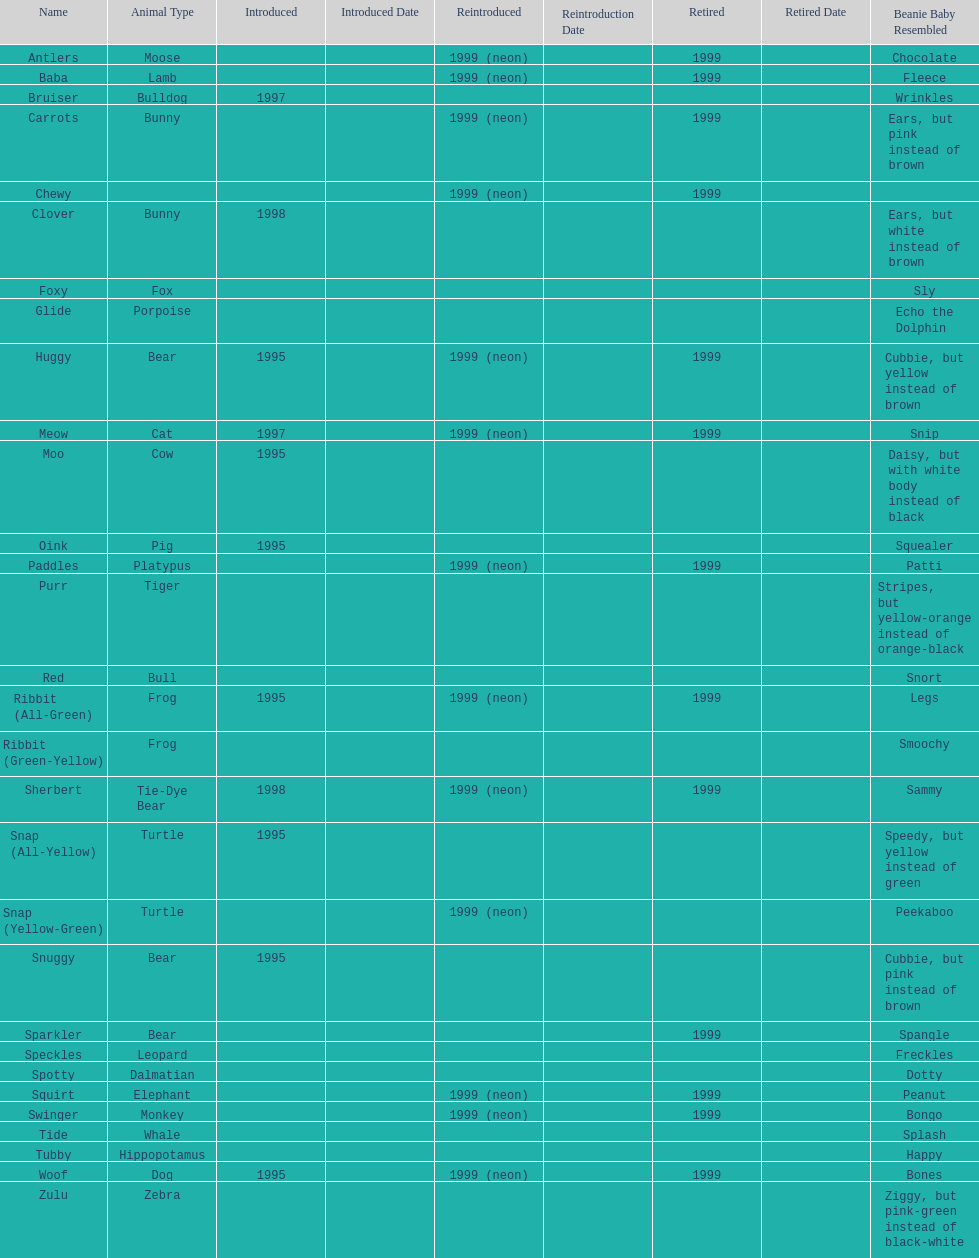What are the total number of pillow pals on this chart? 30. 